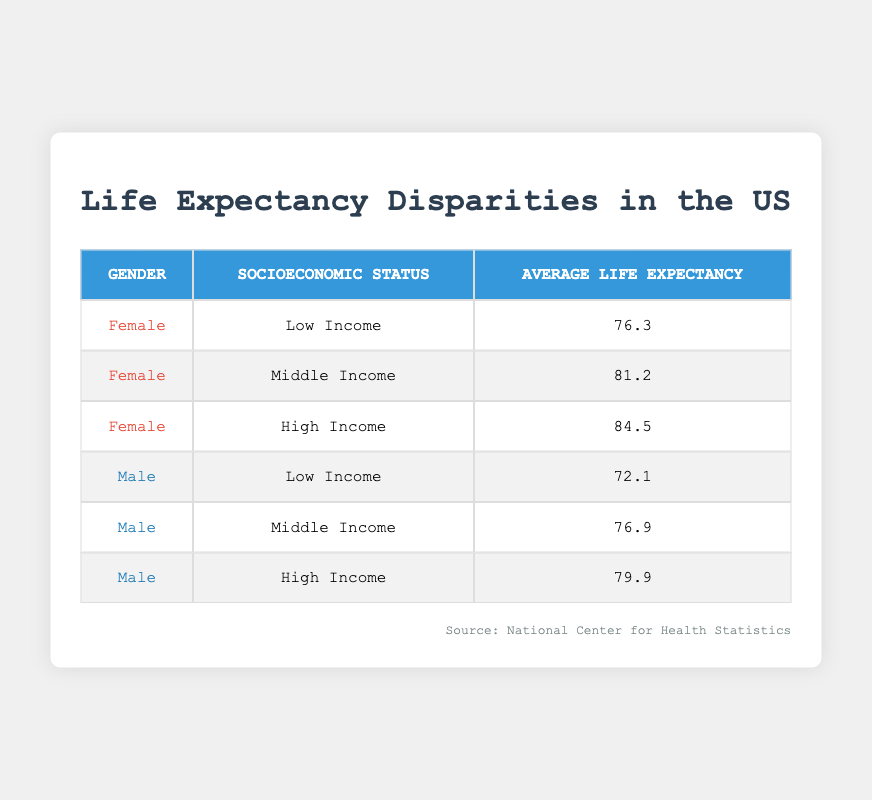What is the average life expectancy for females in high-income households? The table shows that the average life expectancy for females classified under high-income is 84.5 years.
Answer: 84.5 What is the difference in average life expectancy between low-income females and low-income males? For low-income females, the life expectancy is 76.3 years, while for low-income males it is 72.1 years. The difference is calculated as 76.3 - 72.1 = 4.2 years.
Answer: 4.2 Is the average life expectancy for middle-income males higher than for low-income females? The average life expectancy for middle-income males is 76.9 years, while for low-income females it is 76.3 years. Since 76.9 is greater than 76.3, the statement is true.
Answer: Yes What is the average life expectancy across all high-income individuals? The high-income life expectancy data includes females with 84.5 years and males with 79.9 years. To find the average, add these values: 84.5 + 79.9 = 164.4, then divide by 2, resulting in an average of 164.4/2 = 82.2 years.
Answer: 82.2 Which gender and socioeconomic status combination has the lowest average life expectancy? By examining the table, the combination of low-income males has the lowest average life expectancy at 72.1 years.
Answer: Low-income males What is the average life expectancy for females compared to males across all socioeconomic statuses? The average life expectancy for females is calculated as follows: (76.3 + 81.2 + 84.5) / 3 = 80.3333, which rounds to 80.3. For males: (72.1 + 76.9 + 79.9) / 3 = 76.3. Therefore, females have a higher average life expectancy of 80.3 compared to males at 76.3.
Answer: Females have a higher average life expectancy Is there a higher average life expectancy for high-income females compared to middle-income females? Yes, high-income females have an average life expectancy of 84.5, while middle-income females have an average life expectancy of 81.2. Thus, the statement is true.
Answer: Yes What percentage increase in life expectancy do females experience moving from low-income to high-income status? The average life expectancy for low-income females is 76.3, and for high-income females, it is 84.5. The increase is calculated as (84.5 - 76.3) / 76.3 * 100%, which equals approximately 10.3%.
Answer: 10.3% 